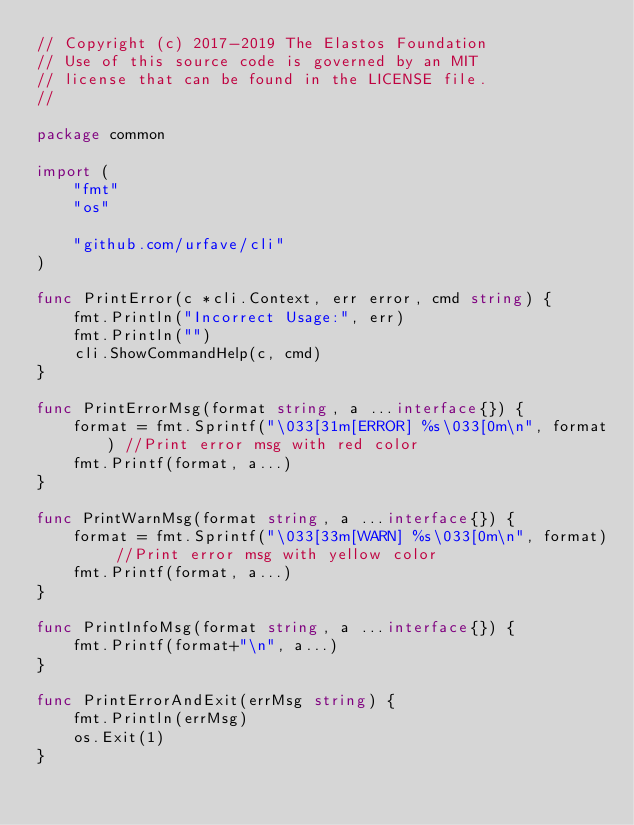<code> <loc_0><loc_0><loc_500><loc_500><_Go_>// Copyright (c) 2017-2019 The Elastos Foundation
// Use of this source code is governed by an MIT
// license that can be found in the LICENSE file.
// 

package common

import (
	"fmt"
	"os"

	"github.com/urfave/cli"
)

func PrintError(c *cli.Context, err error, cmd string) {
	fmt.Println("Incorrect Usage:", err)
	fmt.Println("")
	cli.ShowCommandHelp(c, cmd)
}

func PrintErrorMsg(format string, a ...interface{}) {
	format = fmt.Sprintf("\033[31m[ERROR] %s\033[0m\n", format) //Print error msg with red color
	fmt.Printf(format, a...)
}

func PrintWarnMsg(format string, a ...interface{}) {
	format = fmt.Sprintf("\033[33m[WARN] %s\033[0m\n", format) //Print error msg with yellow color
	fmt.Printf(format, a...)
}

func PrintInfoMsg(format string, a ...interface{}) {
	fmt.Printf(format+"\n", a...)
}

func PrintErrorAndExit(errMsg string) {
	fmt.Println(errMsg)
	os.Exit(1)
}
</code> 